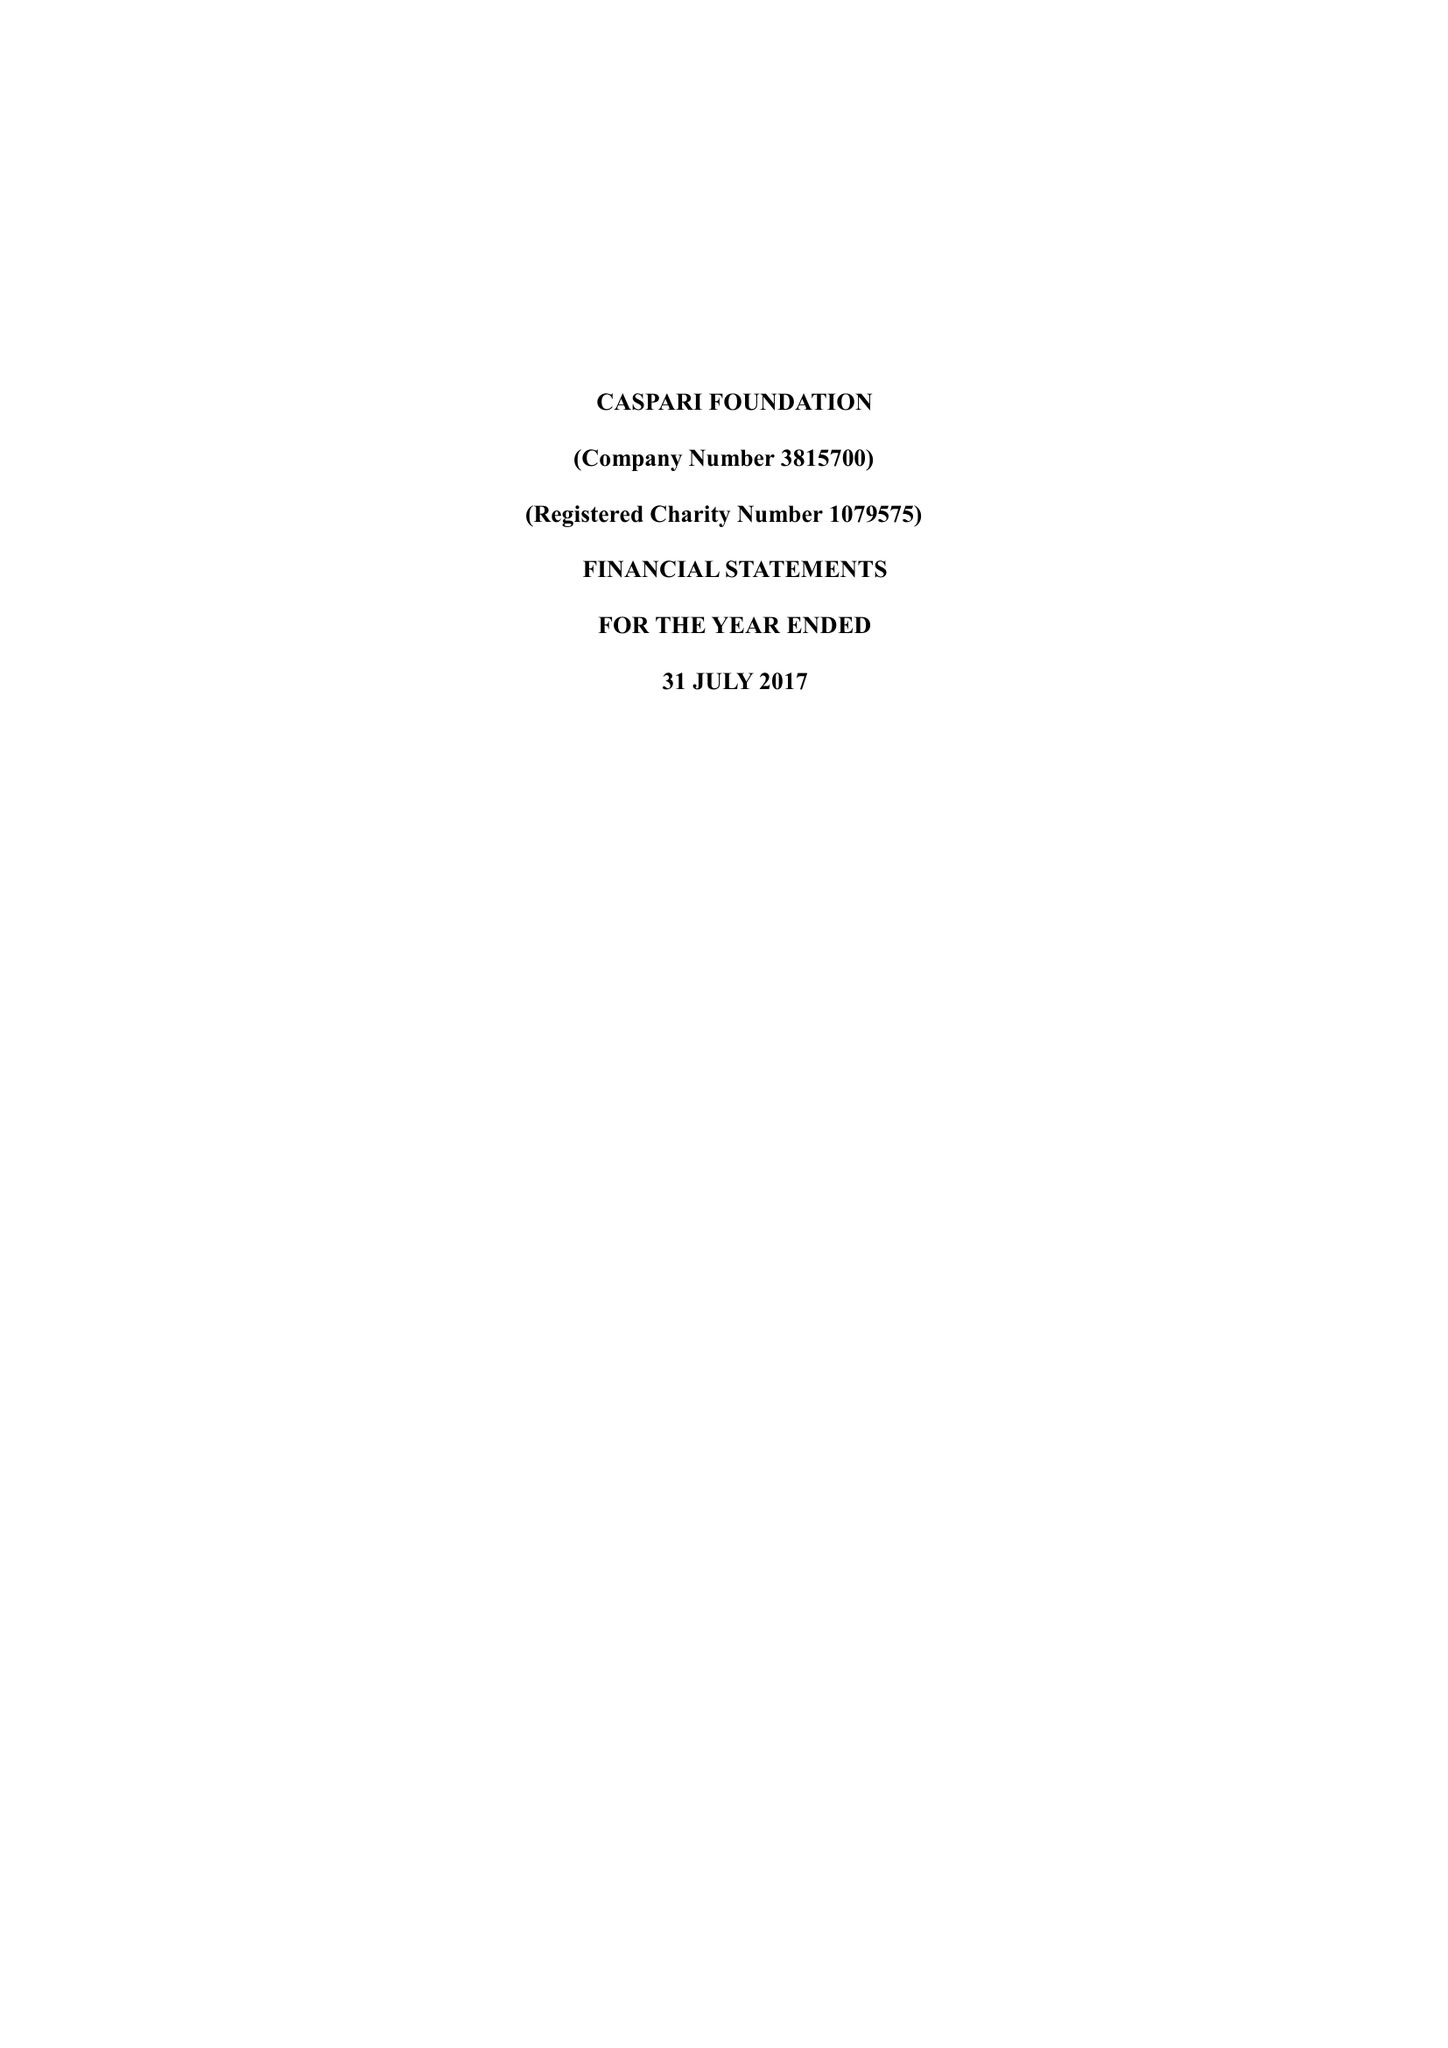What is the value for the address__post_town?
Answer the question using a single word or phrase. LONDON 